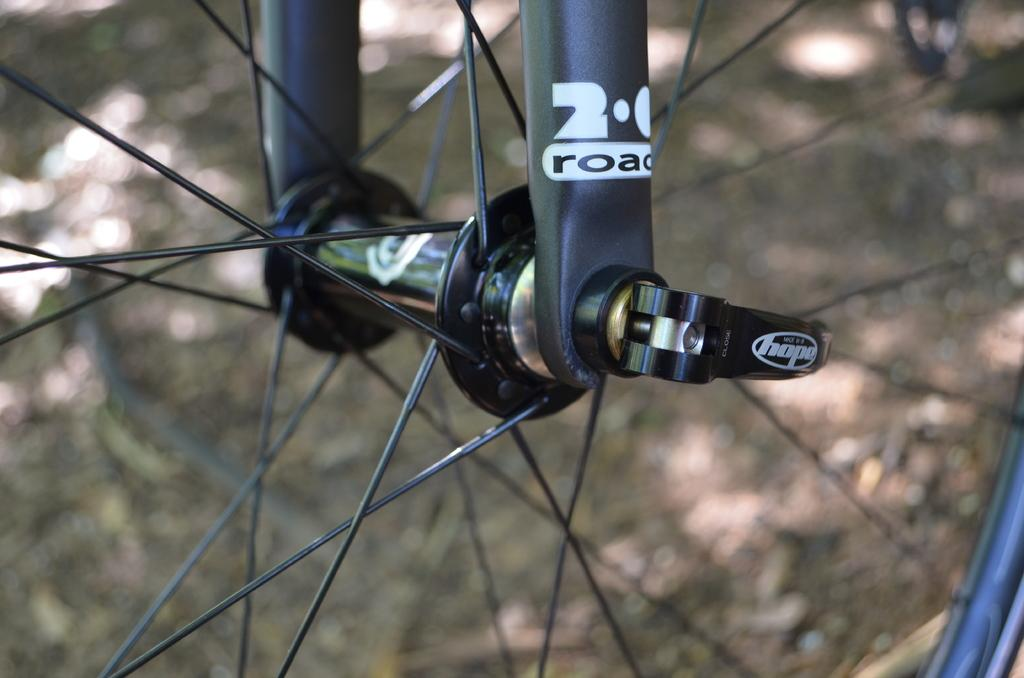What is the main object in the center of the image? There is a wheel in the center of the image. What can be found on the wheel? There is writing on the wheel. How many chickens are sitting on the vase in the image? There is no vase or chicken present in the image; it only features a wheel with writing on it. 